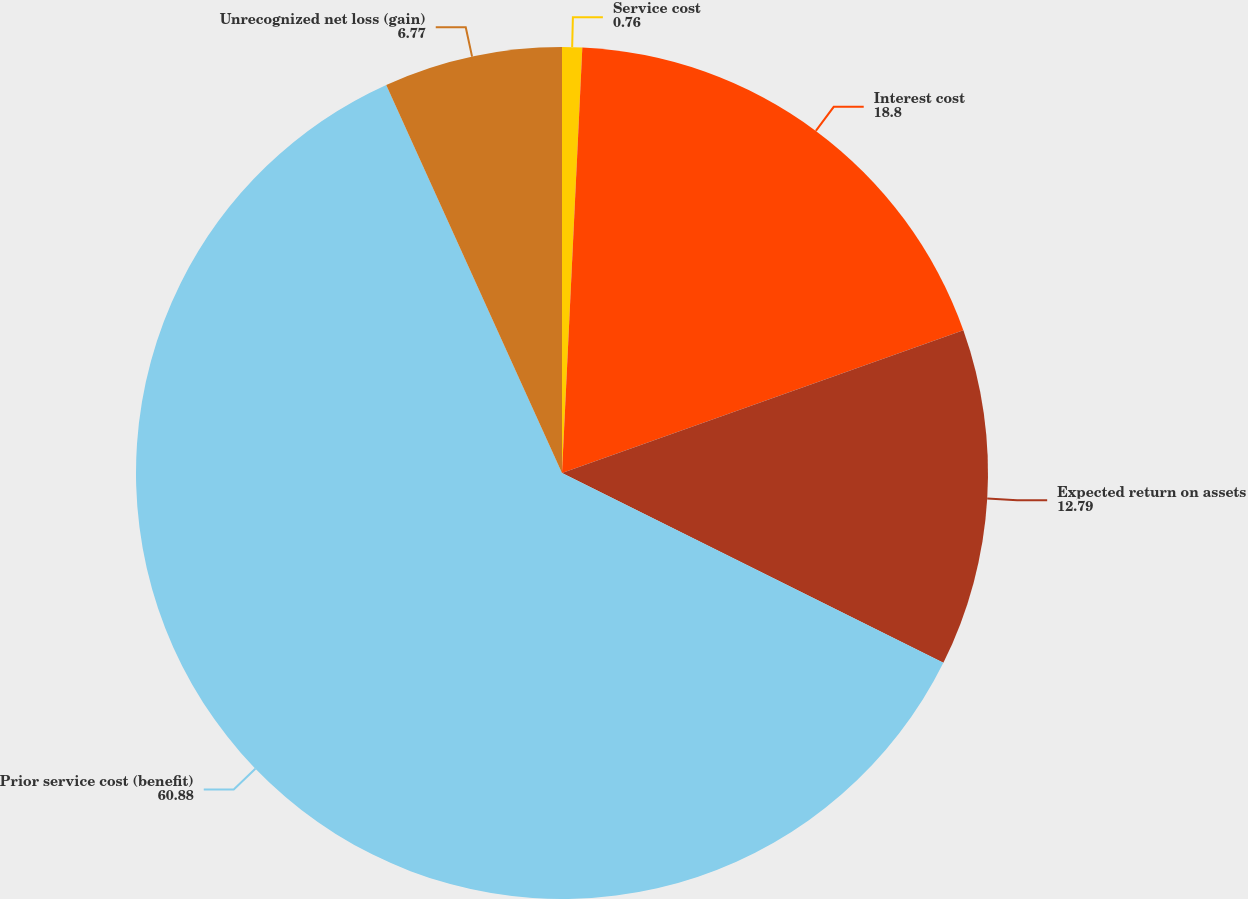Convert chart to OTSL. <chart><loc_0><loc_0><loc_500><loc_500><pie_chart><fcel>Service cost<fcel>Interest cost<fcel>Expected return on assets<fcel>Prior service cost (benefit)<fcel>Unrecognized net loss (gain)<nl><fcel>0.76%<fcel>18.8%<fcel>12.79%<fcel>60.88%<fcel>6.77%<nl></chart> 